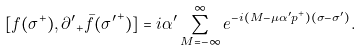<formula> <loc_0><loc_0><loc_500><loc_500>[ f ( \sigma ^ { + } ) , { \partial ^ { \prime } } _ { + } \bar { f } ( { \sigma ^ { \prime } } ^ { + } ) ] = i \alpha ^ { \prime } \sum _ { M = - \infty } ^ { \infty } e ^ { - i ( M - \mu \alpha ^ { \prime } p ^ { + } ) ( \sigma - \sigma ^ { \prime } ) } .</formula> 